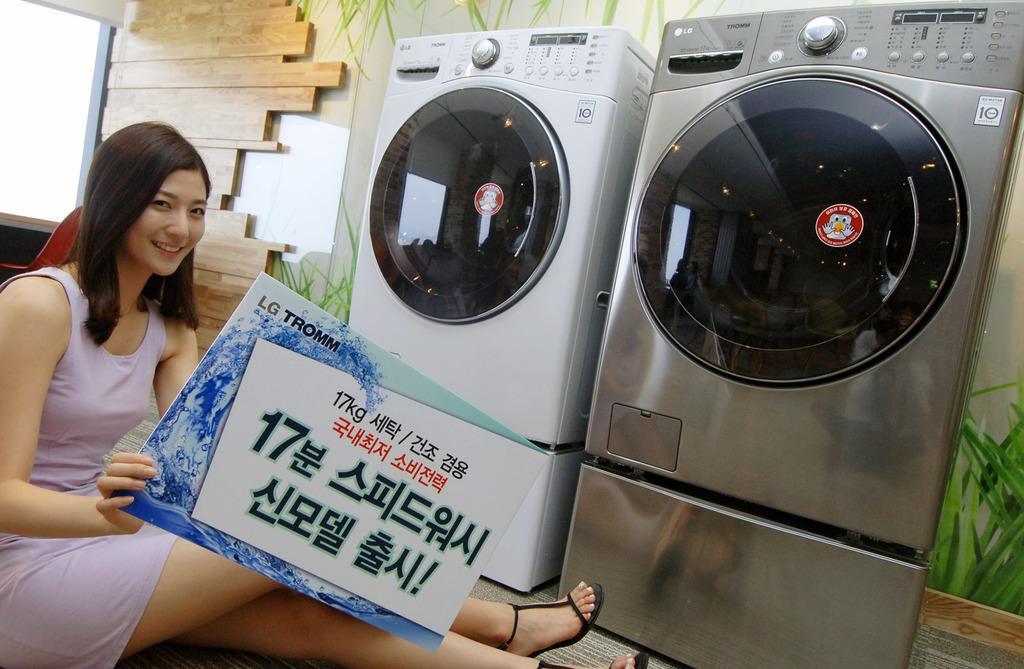Can you describe this image briefly? In the image there are two washing machines and in front of the washing machines there is a woman sitting on the floor and she is holding a poster with her hand, in the background there is a wall. 